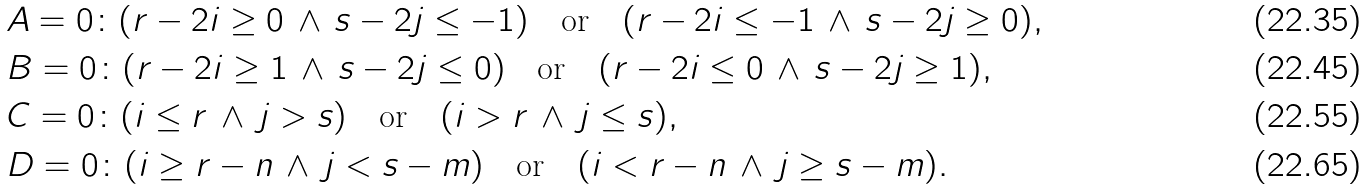Convert formula to latex. <formula><loc_0><loc_0><loc_500><loc_500>& A = 0 \colon ( r - 2 i \geq 0 \, \wedge \, s - 2 j \leq - 1 ) \quad \text {or} \quad ( r - 2 i \leq - 1 \, \wedge \, s - 2 j \geq 0 ) , \\ & B = 0 \colon ( r - 2 i \geq 1 \, \wedge \, s - 2 j \leq 0 ) \quad \text {or} \quad ( r - 2 i \leq 0 \, \wedge \, s - 2 j \geq 1 ) , \\ & C = 0 \colon ( i \leq r \, \wedge \, j > s ) \quad \text {or} \quad ( i > r \, \wedge \, j \leq s ) , \\ & D = 0 \colon ( i \geq r - n \, \wedge \, j < s - m ) \quad \text {or} \quad ( i < r - n \, \wedge \, j \geq s - m ) .</formula> 